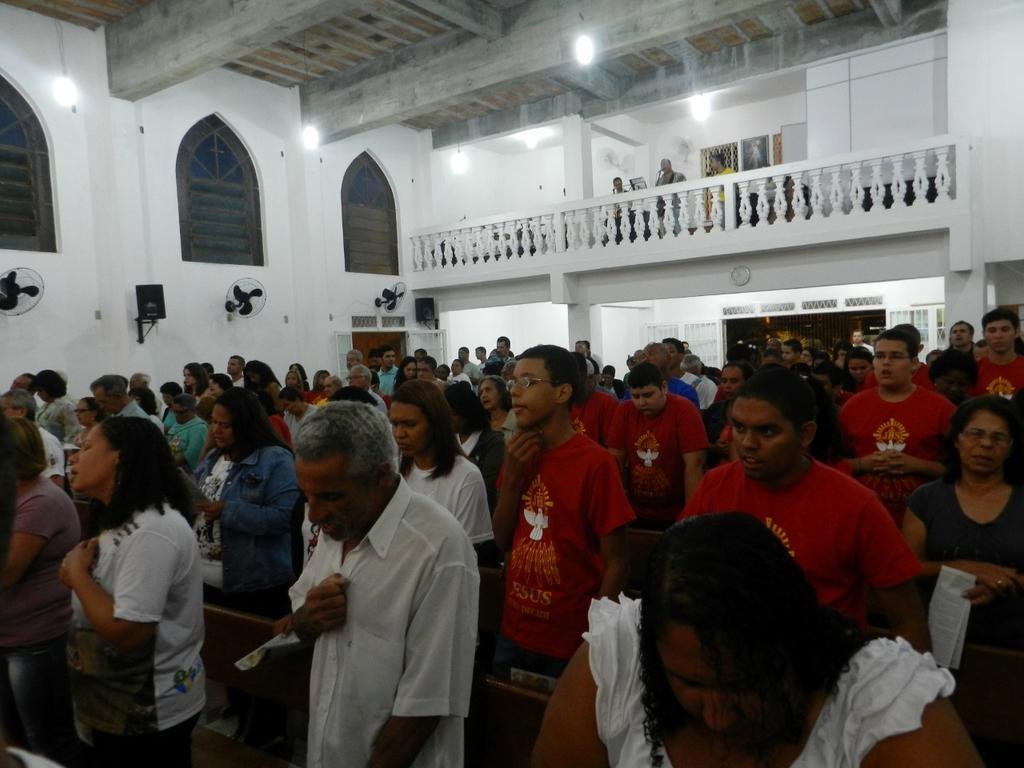In one or two sentences, can you explain what this image depicts? In this image we can see a crowd standing between benches on the floor. In the background we can see orchestra, clock, grill, wall, windows, speakers, fans attached to the wall and electric lights. 